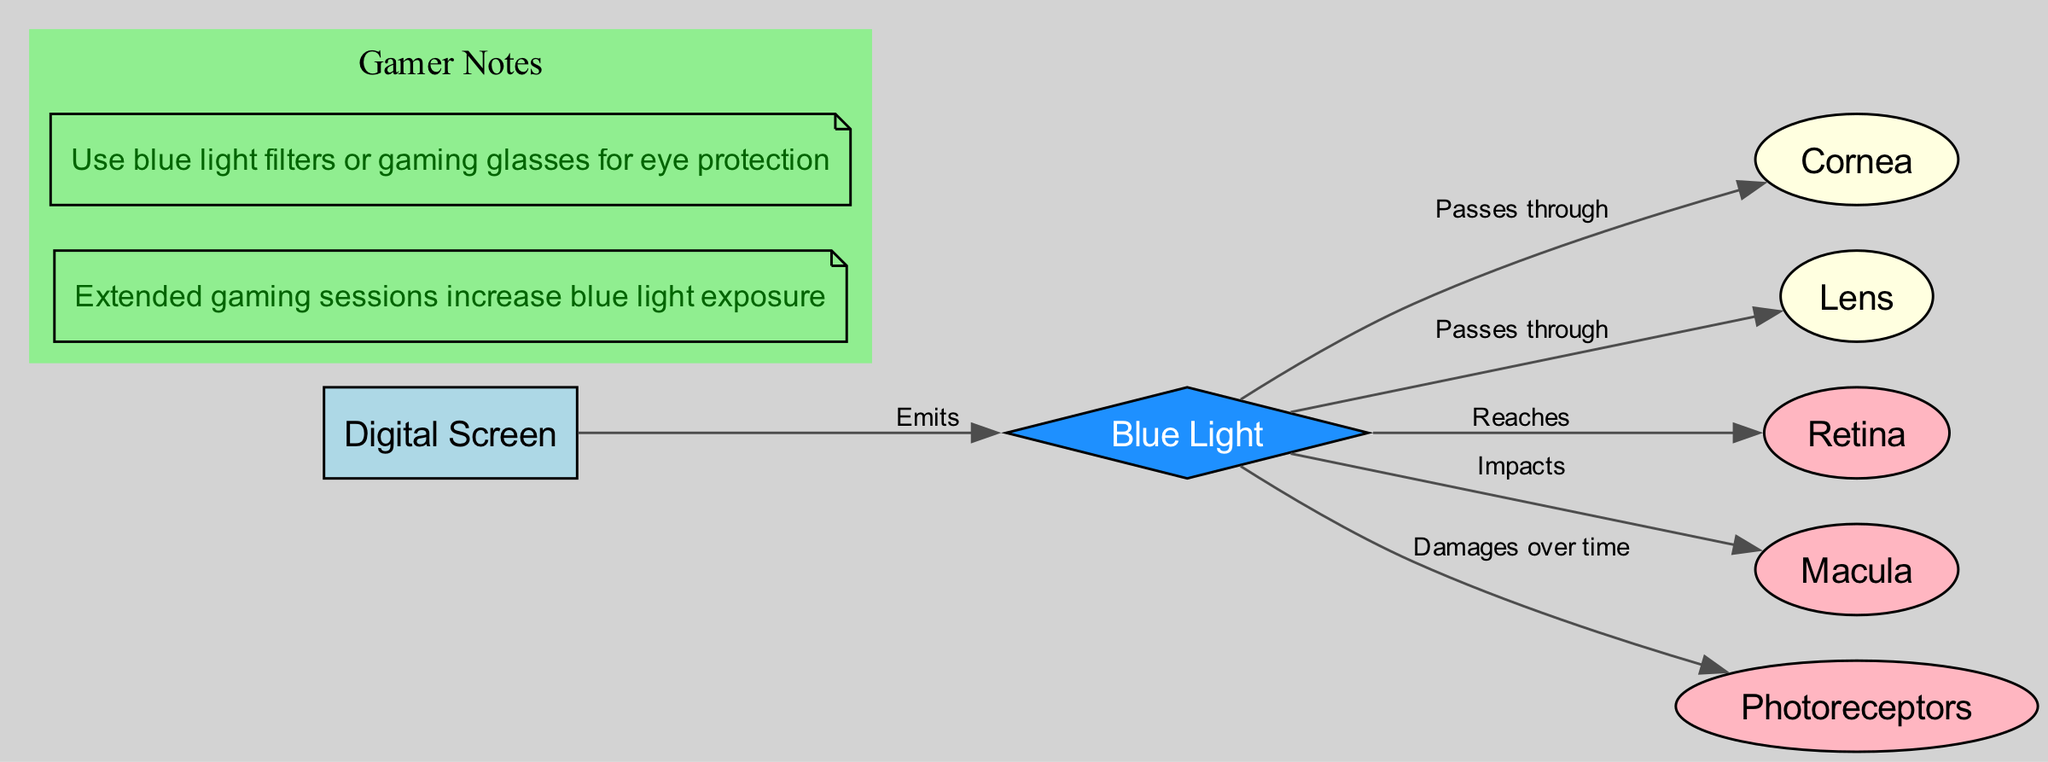What is the source of blue light in the diagram? The diagram indicates that digital screens emit blue light, which is labeled as the 'screen' node that connects to the blue light node through an edge showing the relationship 'Emits'.
Answer: Digital Screen How many nodes are present in the diagram? The diagram includes 7 nodes: Cornea, Lens, Retina, Macula, Blue Light, Photoreceptors, and Digital Screen.
Answer: 7 What part of the eye does blue light impact? The diagram describes that blue light impacts the macula, as shown by the edge labeled 'Impacts' from the blue light node to the macula node.
Answer: Macula What damages the photoreceptors over time? The diagram specifies that blue light damages photoreceptors over time, as shown by the edge labeled 'Damages over time' connecting the blue light node to the photoreceptors node.
Answer: Blue Light What can be used for eye protection against blue light? The annotations in the diagram provide a tip indicating the use of blue light filters or gaming glasses for eye protection, showcasing the need for protective measures against blue light exposure.
Answer: Blue light filters or gaming glasses What structure do blue light rays pass through after the cornea? The diagram shows that after passing through the cornea, blue light rays continue to pass through the lens, as indicated by the edge labeled 'Passes through' connecting the blue light node to the lens node.
Answer: Lens Which part follows the lens in the path of blue light exposure? From the diagram, blue light passes through the lens and then reaches the retina, as illustrated by the edge labeled 'Reaches'. Thus, the retina is the next structure in the sequence after the lens.
Answer: Retina During extended gaming sessions, what happens to blue light exposure? The annotation labeled as a 'Gamer Note' in the diagram states that extended gaming sessions increase blue light exposure, linking gaming habits with eye strain.
Answer: Increases What node is connected to blue light with a direct relationship to 'passes through'? The diagram shows that blue light passes through both the cornea and the lens, but specifically mentions 'passes through' from the blue light node to both of these ocular structures. Therefore, both terms could be correct, but since the question focuses specifically on the sequential path from the blue light, the first destination is the cornea.
Answer: Cornea 